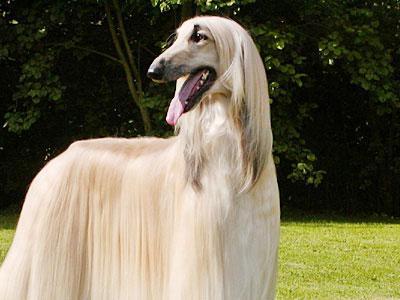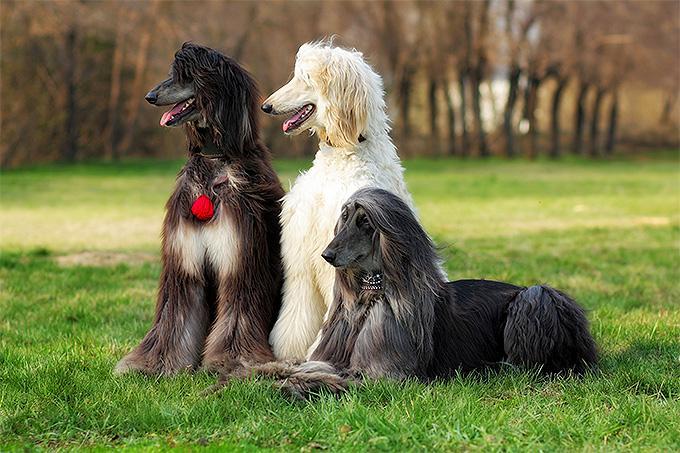The first image is the image on the left, the second image is the image on the right. Evaluate the accuracy of this statement regarding the images: "One image features at least two dogs.". Is it true? Answer yes or no. Yes. 